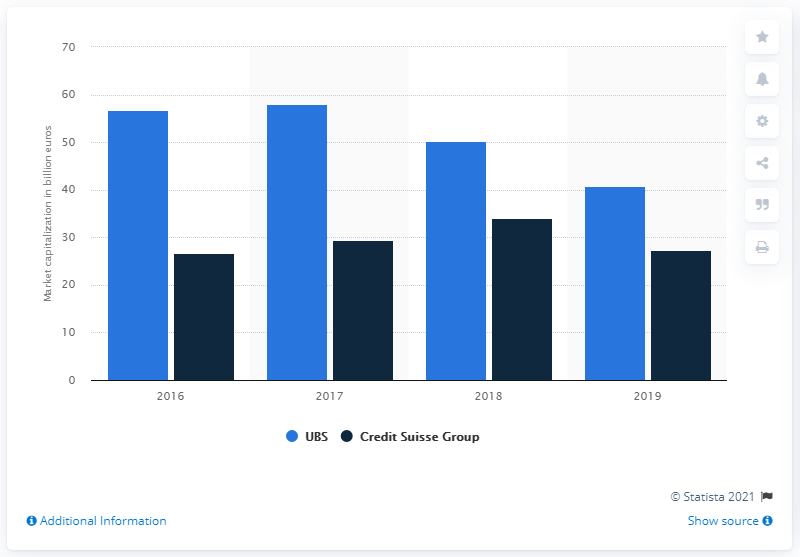Mention a couple of crucial points in this snapshot. As of July 1st, 2019, the market capital of UBS was 40.69. UBS was the leading Swiss bank with the largest market capitalization among its peers. 